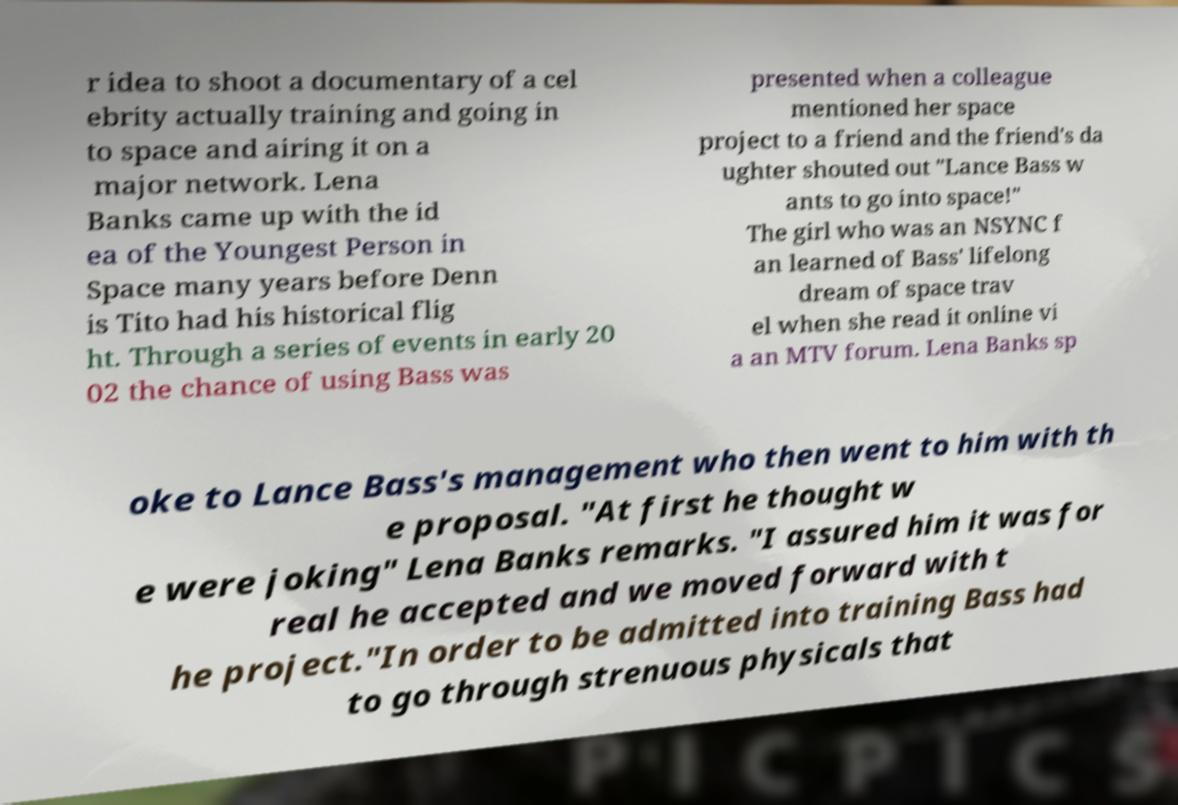There's text embedded in this image that I need extracted. Can you transcribe it verbatim? r idea to shoot a documentary of a cel ebrity actually training and going in to space and airing it on a major network. Lena Banks came up with the id ea of the Youngest Person in Space many years before Denn is Tito had his historical flig ht. Through a series of events in early 20 02 the chance of using Bass was presented when a colleague mentioned her space project to a friend and the friend's da ughter shouted out "Lance Bass w ants to go into space!" The girl who was an NSYNC f an learned of Bass' lifelong dream of space trav el when she read it online vi a an MTV forum. Lena Banks sp oke to Lance Bass's management who then went to him with th e proposal. "At first he thought w e were joking" Lena Banks remarks. "I assured him it was for real he accepted and we moved forward with t he project."In order to be admitted into training Bass had to go through strenuous physicals that 